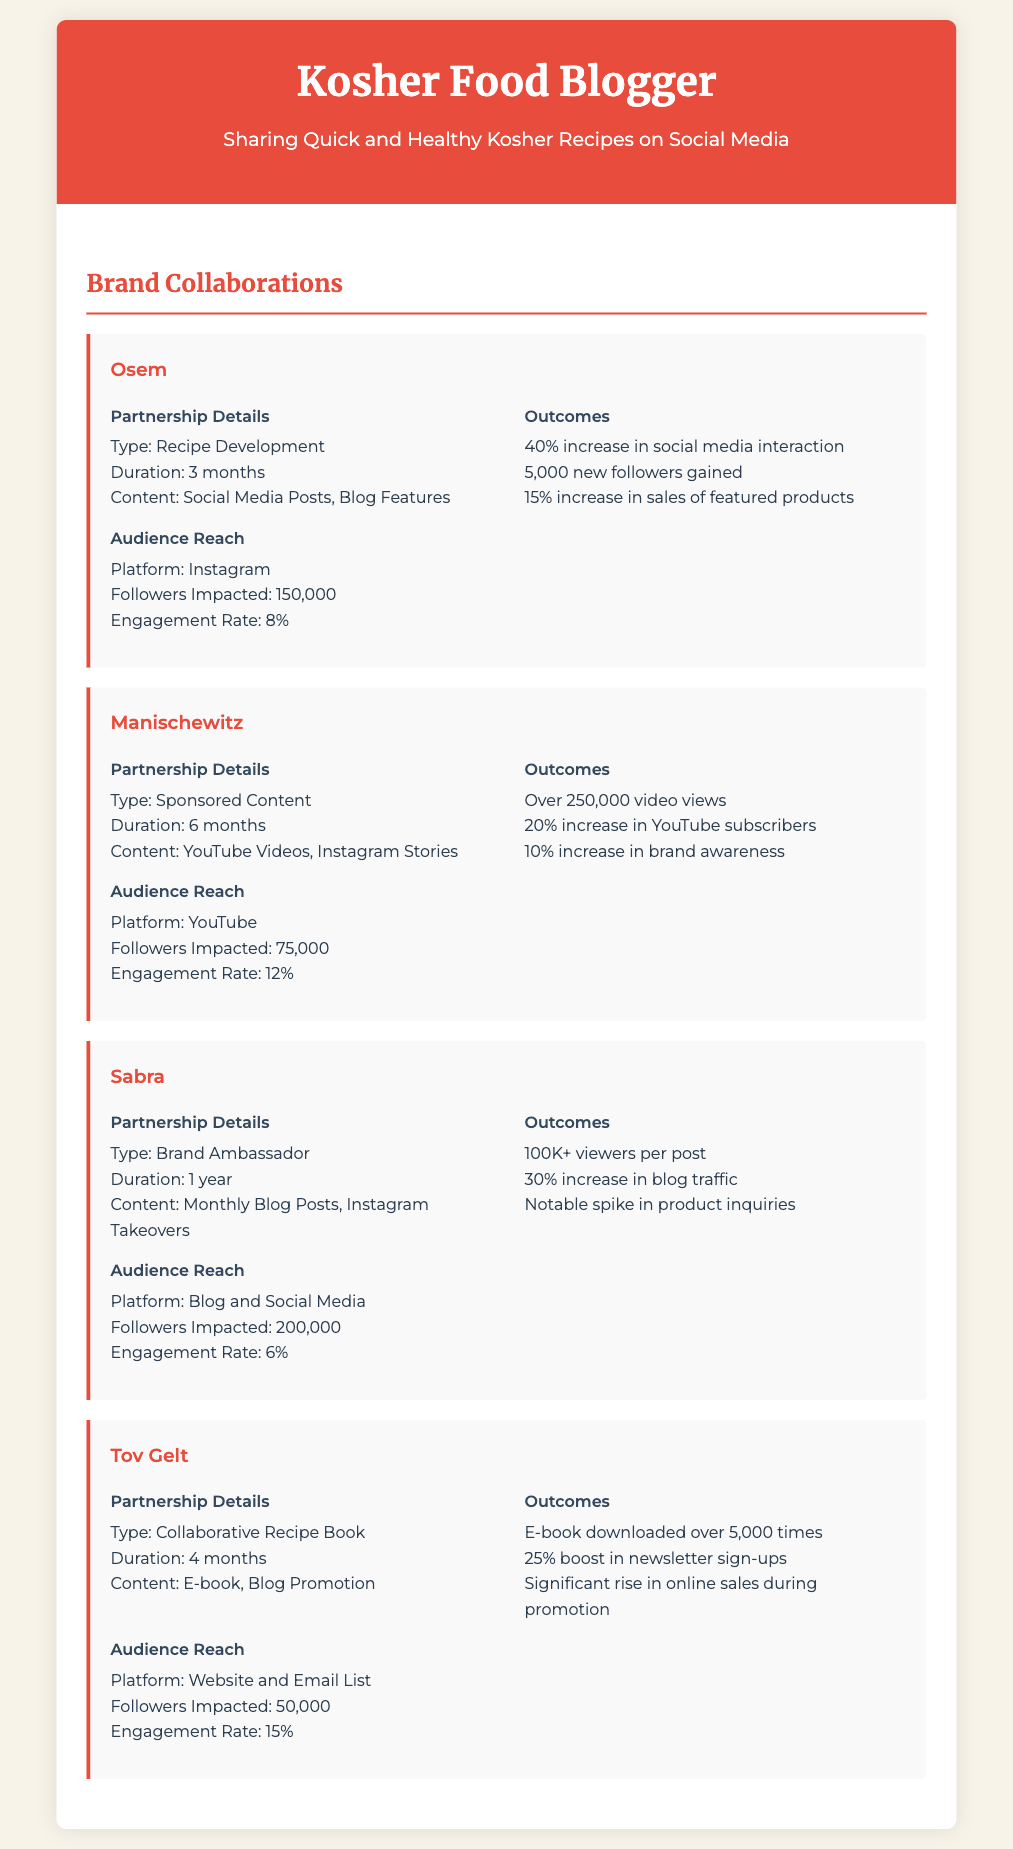What type of partnership was established with Osem? The document states that the partnership with Osem was for recipe development.
Answer: Recipe Development How long did the collaboration with Manischewitz last? The collaboration with Manischewitz lasted for 6 months.
Answer: 6 months What was the engagement rate for the Sabra partnership? The document indicates that the engagement rate for the Sabra partnership was 6%.
Answer: 6% How many new followers were gained from the Osem collaboration? According to the document, 5,000 new followers were gained from the Osem collaboration.
Answer: 5,000 What was the main content type created for the Tov Gelt collaboration? The main content type for the Tov Gelt collaboration was an E-book.
Answer: E-book What platform was primarily used for the Sabra partnership? The document indicates that the primary platform used for the Sabra partnership was the blog and social media.
Answer: Blog and Social Media How many downloads did the Tov Gelt e-book achieve? The document states that the e-book was downloaded over 5,000 times.
Answer: Over 5,000 times What was the main outcome of the Manischewitz collaboration? The outcome included over 250,000 video views from the Manischewitz collaboration.
Answer: Over 250,000 video views What duration characterized the Sabra partnership? The partnership with Sabra was characterized by a duration of 1 year.
Answer: 1 year 